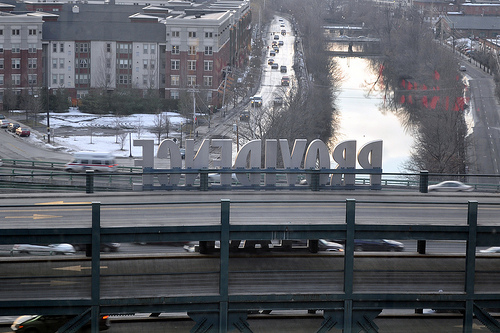<image>
Is there a car to the left of the river? No. The car is not to the left of the river. From this viewpoint, they have a different horizontal relationship. 